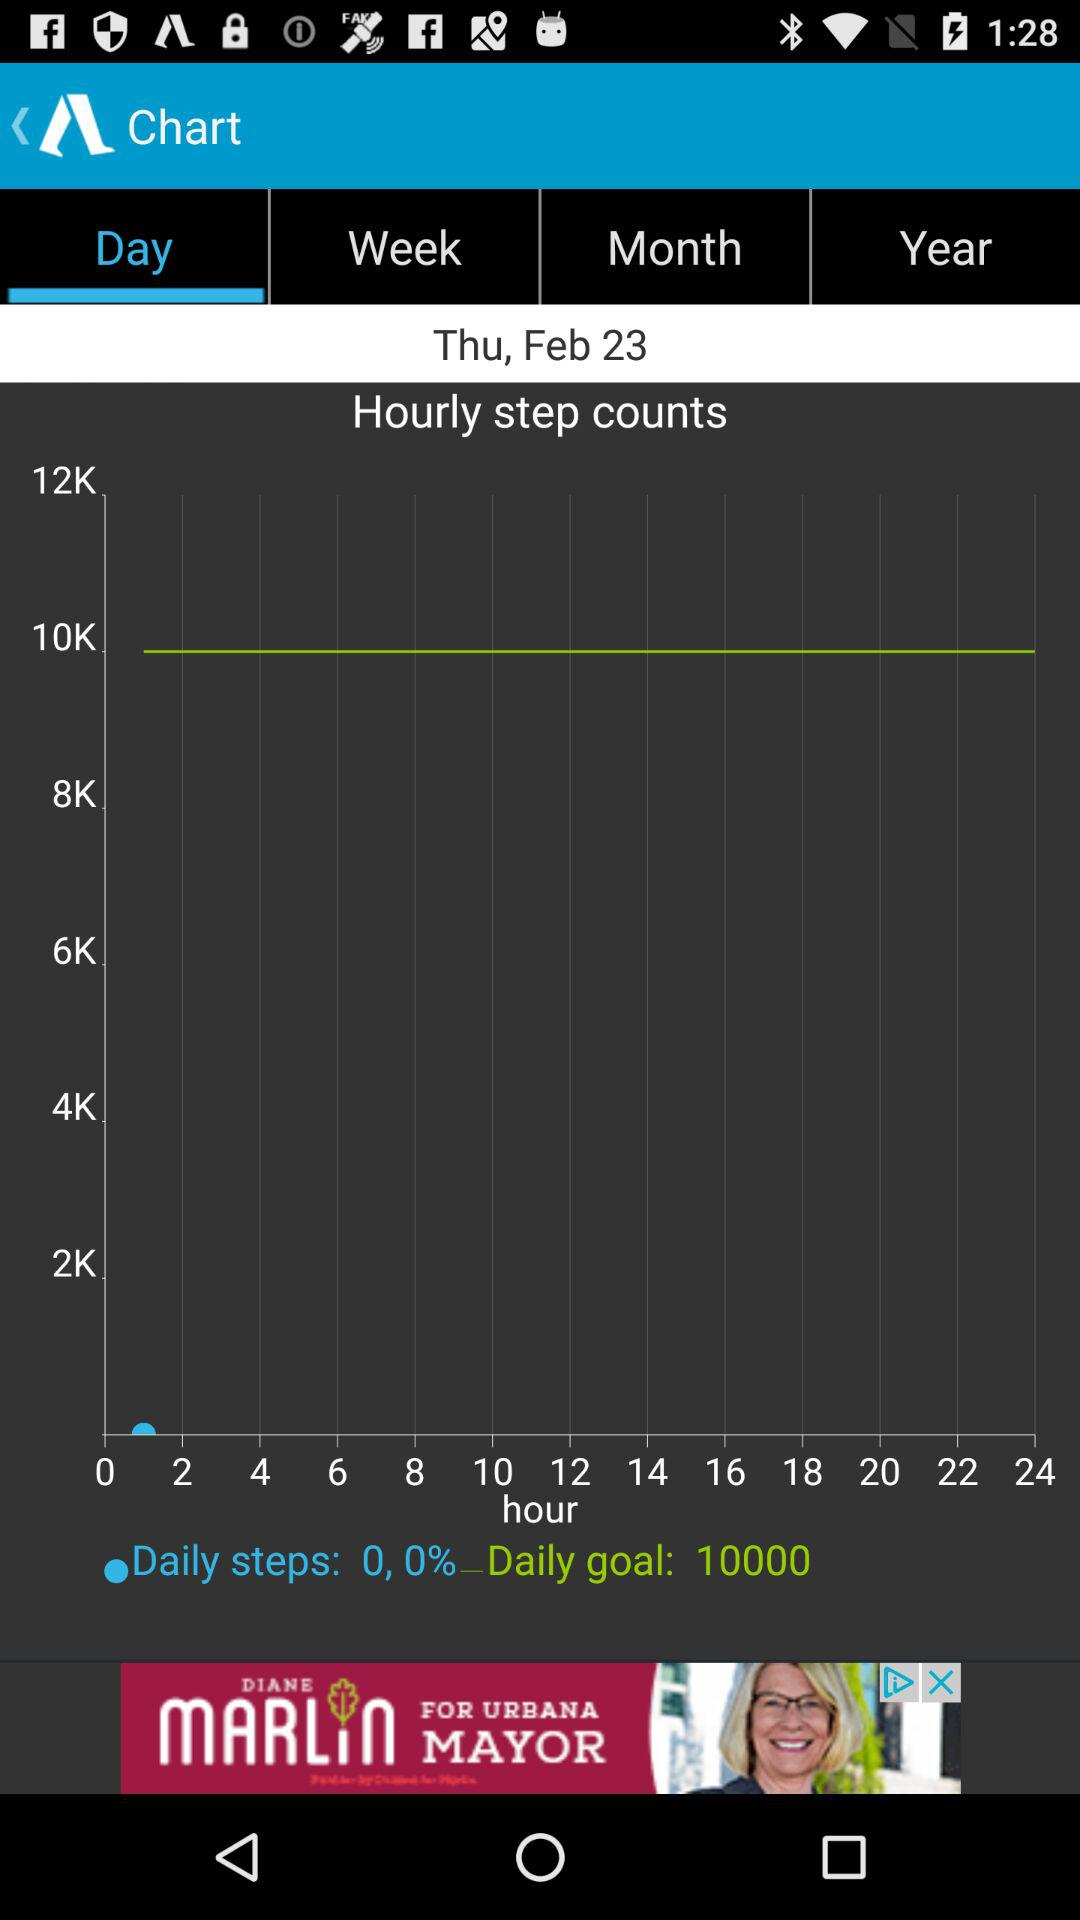What is the year?
When the provided information is insufficient, respond with <no answer>. <no answer> 